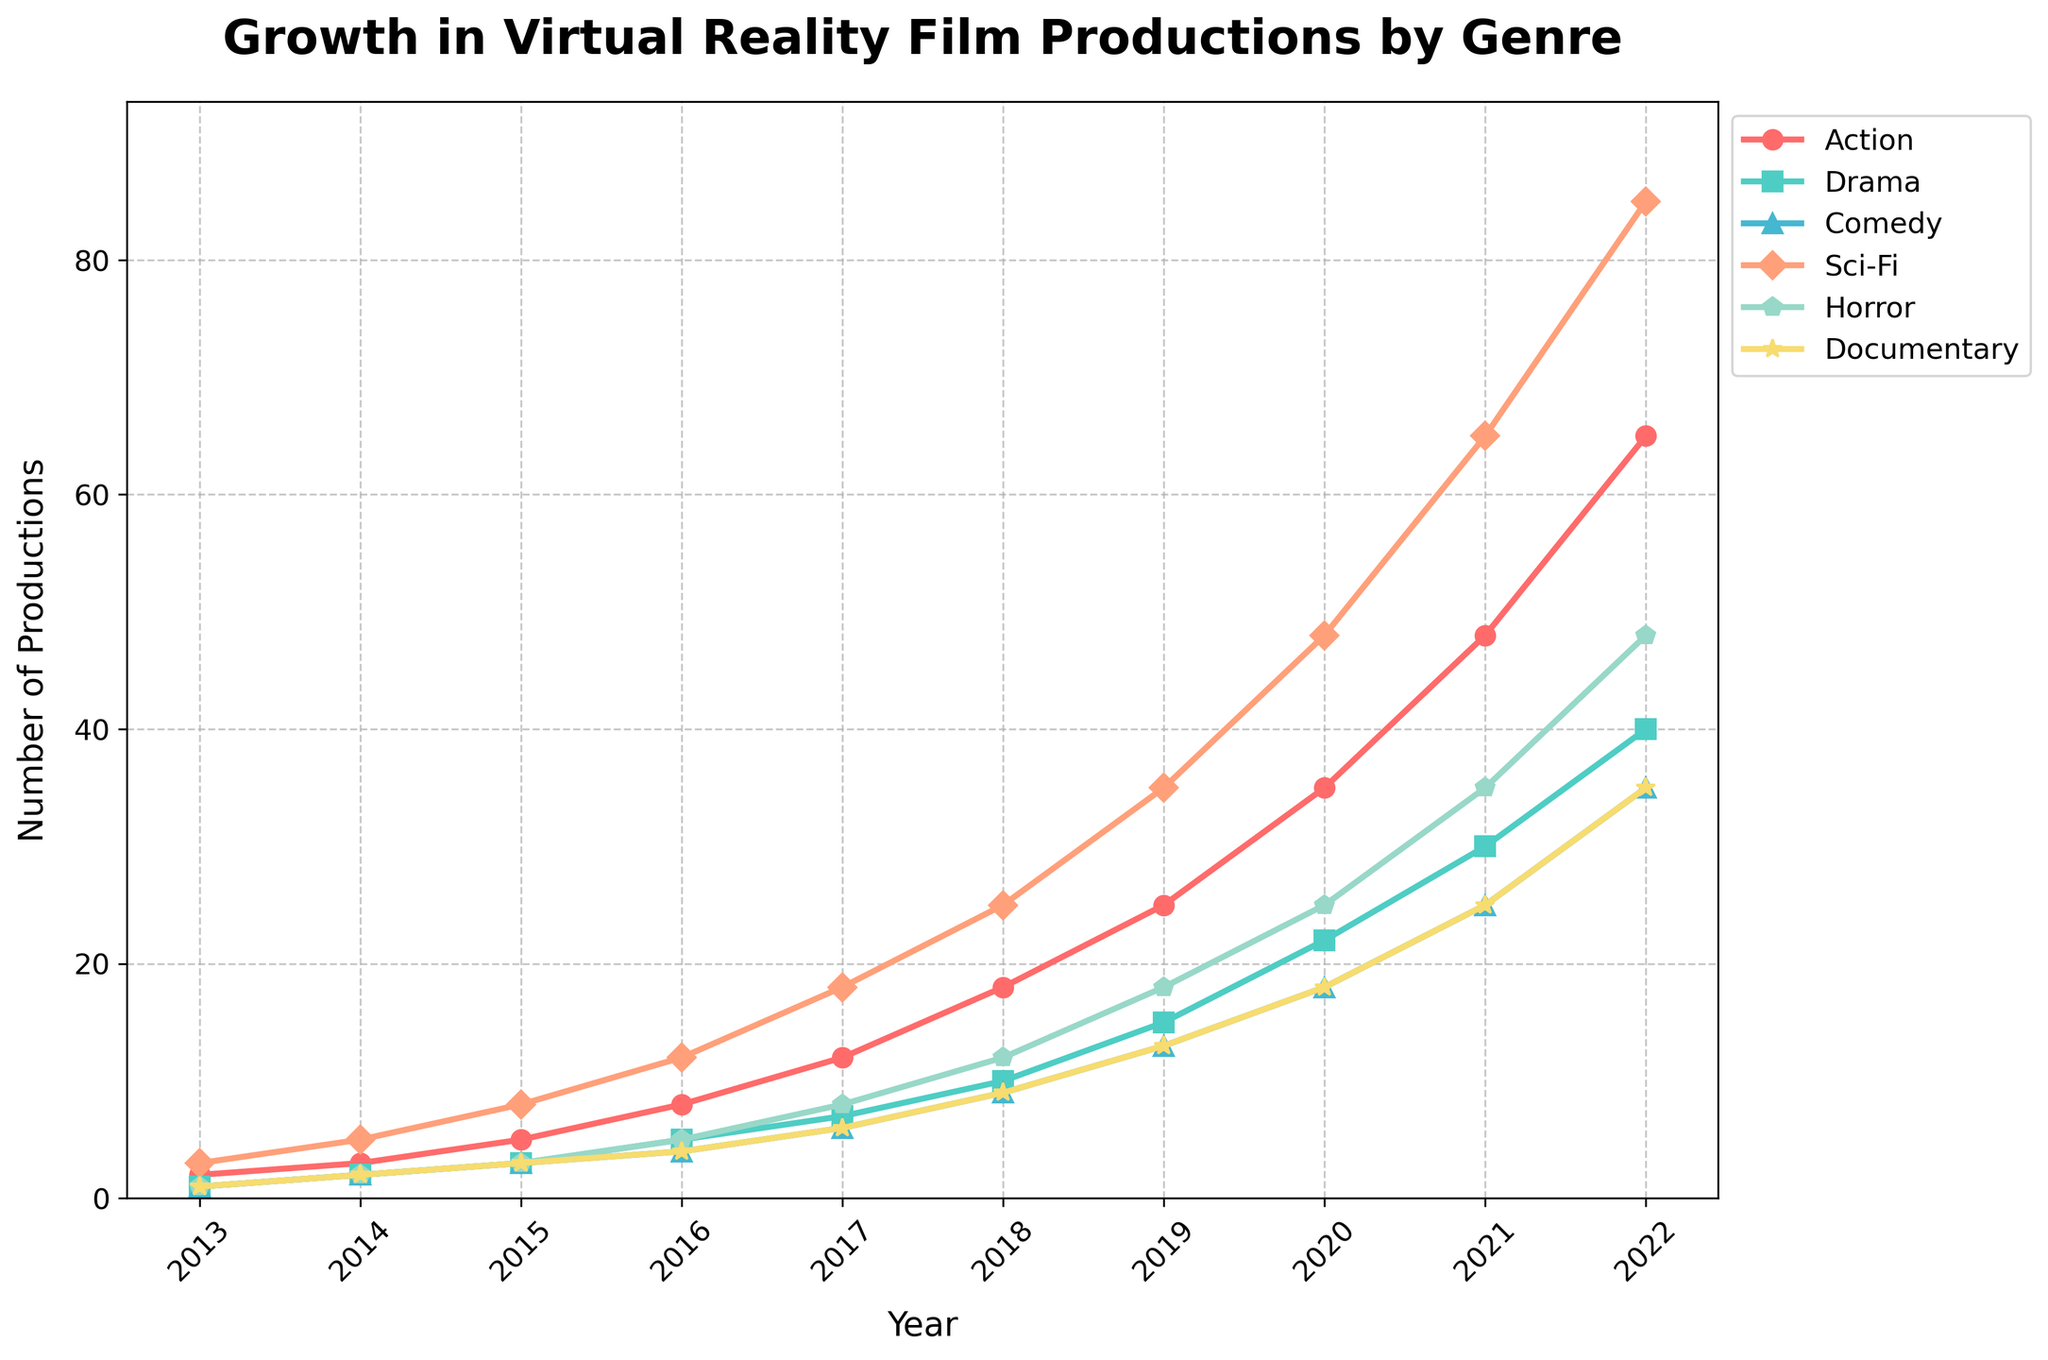What's the difference in the number of Sci-Fi and Horror film productions in 2022? To find the difference, look at the values for Sci-Fi and Horror in 2022. Sci-Fi has 85 productions, and Horror has 48 productions. The difference is 85 - 48.
Answer: 37 Among all genres, which had the highest number of film productions in 2020? Check the values for all genres in 2020. The numbers are: Action (35), Drama (22), Comedy (18), Sci-Fi (48), Horror (25), Documentary (18). The highest value is 48 for Sci-Fi.
Answer: Sci-Fi What is the average number of Action films produced per year over the decade? Sum the number of Action films from 2013 to 2022: 2 + 3 + 5 + 8 + 12 + 18 + 25 + 35 + 48 + 65 = 221. Then, divide by the number of years (10).
Answer: 22.1 Which genre has the steepest growth trend over the past decade? Visually inspect the slope of each line from 2013 to 2022. The Sci-Fi genre has the steepest curve, indicating the highest rate of growth.
Answer: Sci-Fi How does the number of Documentary films in 2018 compare to the number of Drama films in 2015? In 2018, there are 9 Documentary films, and in 2015, there are 3 Drama films. Documentary productions are higher.
Answer: Documentary is higher Which genre shows the least variation in production numbers over the past decade? Examine the lines for all genres. The Documentary genre has the least steep curve and least variation from year to year.
Answer: Documentary In which year did Action films surpass 20 productions? Look at the values for Action films and find the first year where the number is greater than 20. The value surpasses 20 in 2019.
Answer: 2019 In 2017, how many more Action films were produced compared to Comedy films? In 2017, Action films are 12 and Comedy films are 6. The difference is 12 - 6.
Answer: 6 What is the total number of Comedy films produced from 2013 to 2016? Sum the number of Comedy films from 2013 to 2016: 1 + 2 + 3 + 4. The total is 10.
Answer: 10 Which year had the highest combined total number of film productions across all genres? Sum the numbers from each year across all genres and find the year with the highest value. 2022 has the highest combined total with the sum being 65 + 40 + 35 + 85 + 48 + 35 = 308.
Answer: 2022 